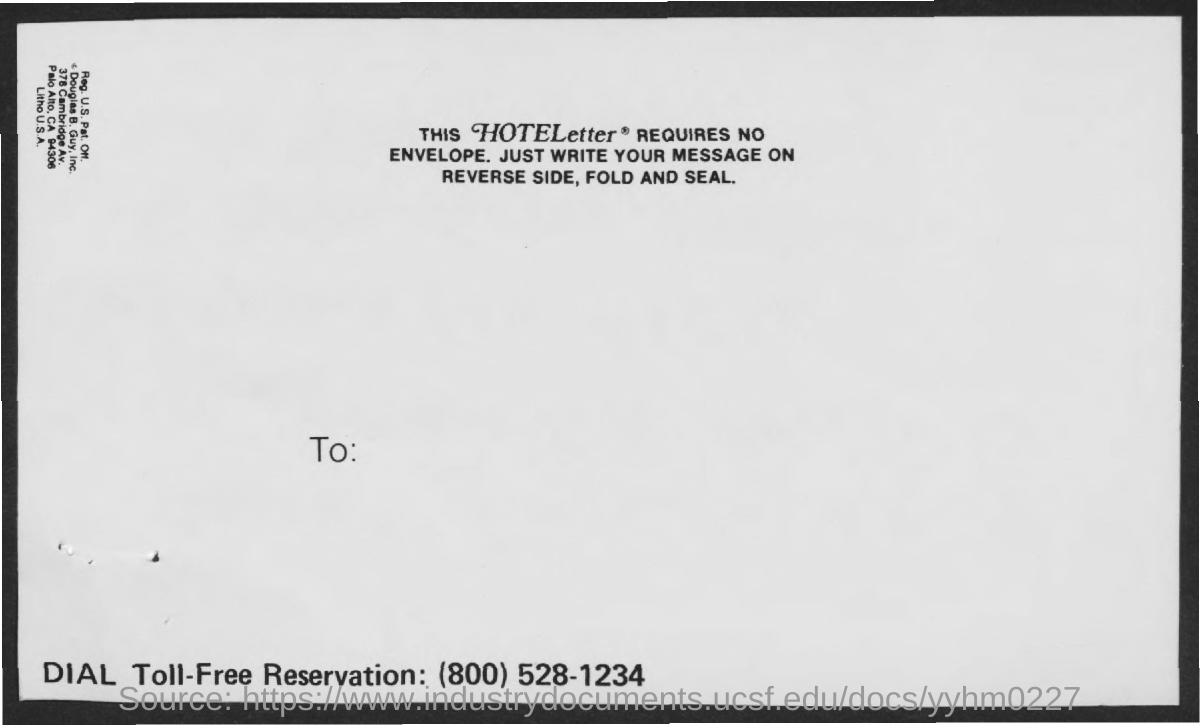What is the toll-free reservation no given?
Offer a terse response. (800) 528-1234. 